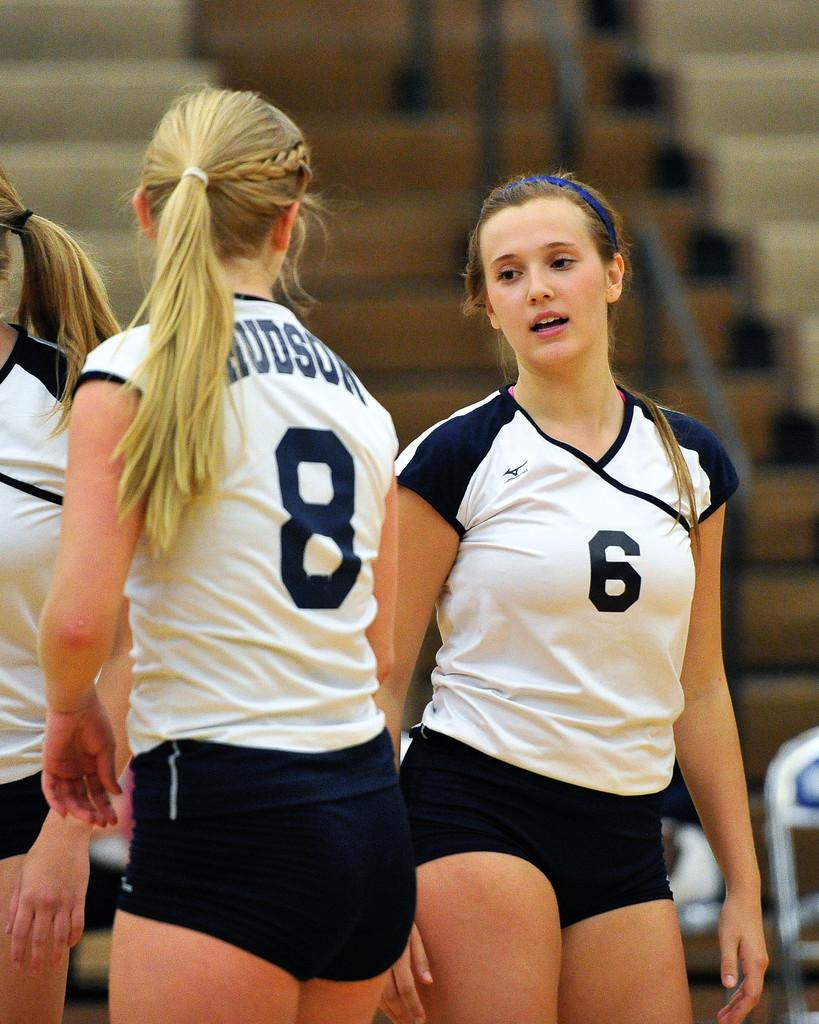Provide a one-sentence caption for the provided image. tow girls on a team are numbers six and eight. 